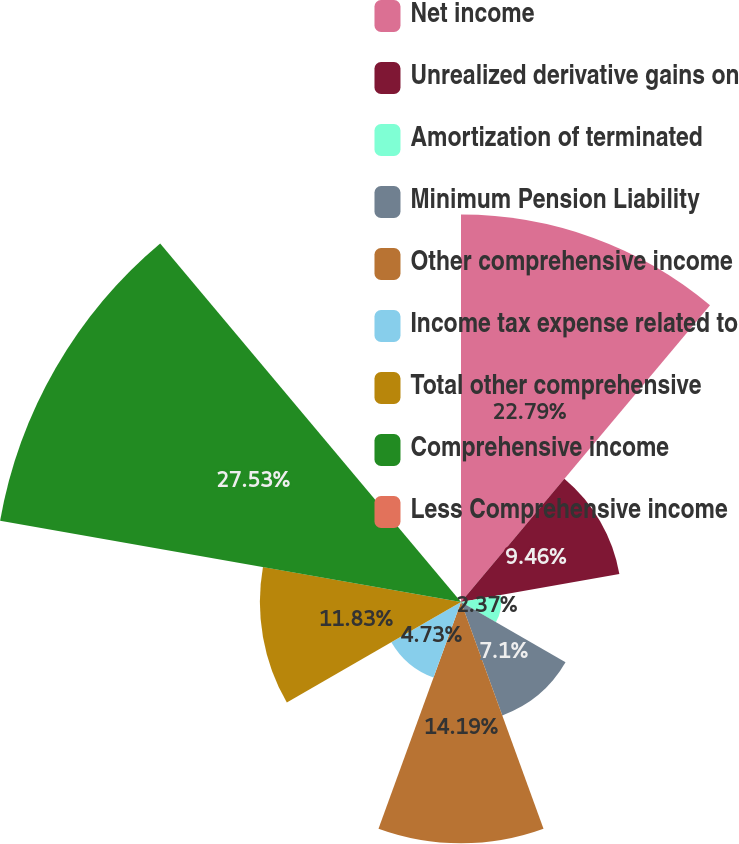<chart> <loc_0><loc_0><loc_500><loc_500><pie_chart><fcel>Net income<fcel>Unrealized derivative gains on<fcel>Amortization of terminated<fcel>Minimum Pension Liability<fcel>Other comprehensive income<fcel>Income tax expense related to<fcel>Total other comprehensive<fcel>Comprehensive income<fcel>Less Comprehensive income<nl><fcel>22.79%<fcel>9.46%<fcel>2.37%<fcel>7.1%<fcel>14.19%<fcel>4.73%<fcel>11.83%<fcel>27.53%<fcel>0.0%<nl></chart> 